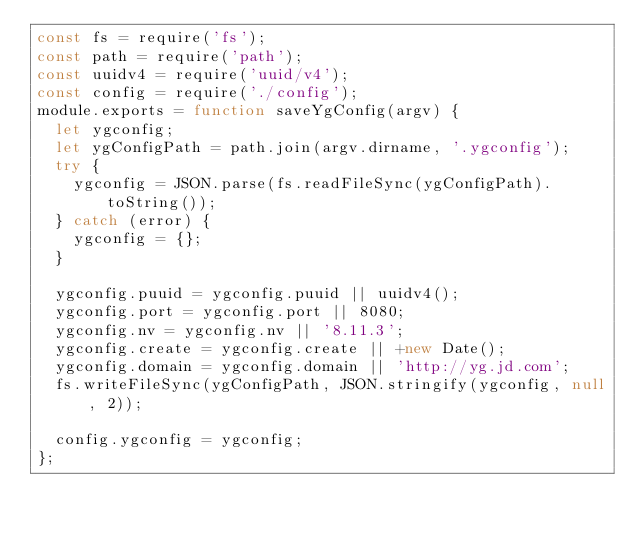<code> <loc_0><loc_0><loc_500><loc_500><_JavaScript_>const fs = require('fs');
const path = require('path');
const uuidv4 = require('uuid/v4');
const config = require('./config');
module.exports = function saveYgConfig(argv) {
  let ygconfig;
  let ygConfigPath = path.join(argv.dirname, '.ygconfig');
  try {
    ygconfig = JSON.parse(fs.readFileSync(ygConfigPath).toString());
  } catch (error) {
    ygconfig = {};
  }

  ygconfig.puuid = ygconfig.puuid || uuidv4();
  ygconfig.port = ygconfig.port || 8080;
  ygconfig.nv = ygconfig.nv || '8.11.3';
  ygconfig.create = ygconfig.create || +new Date();
  ygconfig.domain = ygconfig.domain || 'http://yg.jd.com';
  fs.writeFileSync(ygConfigPath, JSON.stringify(ygconfig, null, 2));

  config.ygconfig = ygconfig;
};
</code> 